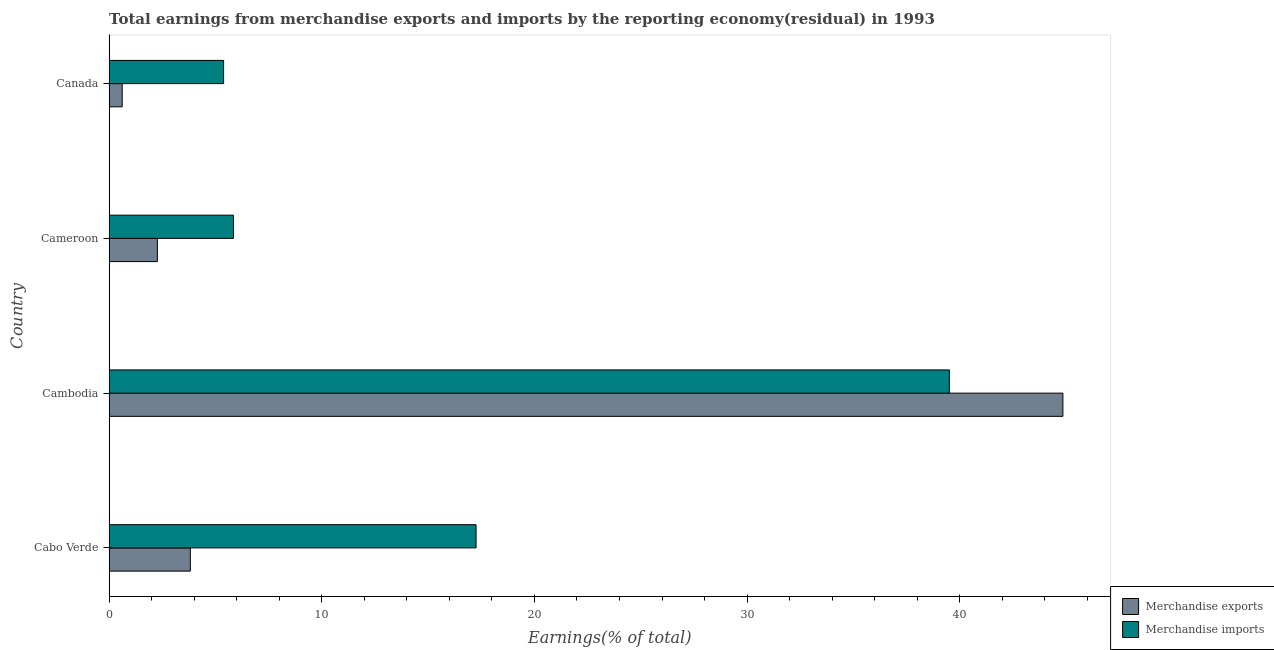How many groups of bars are there?
Offer a very short reply. 4. Are the number of bars per tick equal to the number of legend labels?
Offer a terse response. Yes. In how many cases, is the number of bars for a given country not equal to the number of legend labels?
Offer a terse response. 0. What is the earnings from merchandise exports in Cameroon?
Offer a very short reply. 2.27. Across all countries, what is the maximum earnings from merchandise imports?
Offer a very short reply. 39.51. Across all countries, what is the minimum earnings from merchandise imports?
Give a very brief answer. 5.39. In which country was the earnings from merchandise exports maximum?
Ensure brevity in your answer.  Cambodia. What is the total earnings from merchandise exports in the graph?
Ensure brevity in your answer.  51.56. What is the difference between the earnings from merchandise imports in Cabo Verde and that in Cambodia?
Make the answer very short. -22.26. What is the difference between the earnings from merchandise imports in Cameroon and the earnings from merchandise exports in Cabo Verde?
Keep it short and to the point. 2.03. What is the average earnings from merchandise exports per country?
Provide a short and direct response. 12.89. What is the difference between the earnings from merchandise exports and earnings from merchandise imports in Canada?
Offer a terse response. -4.77. In how many countries, is the earnings from merchandise exports greater than 14 %?
Ensure brevity in your answer.  1. What is the ratio of the earnings from merchandise imports in Cabo Verde to that in Canada?
Give a very brief answer. 3.2. What is the difference between the highest and the second highest earnings from merchandise imports?
Provide a short and direct response. 22.26. What is the difference between the highest and the lowest earnings from merchandise exports?
Offer a terse response. 44.23. In how many countries, is the earnings from merchandise imports greater than the average earnings from merchandise imports taken over all countries?
Keep it short and to the point. 2. Is the sum of the earnings from merchandise exports in Cameroon and Canada greater than the maximum earnings from merchandise imports across all countries?
Give a very brief answer. No. What does the 1st bar from the top in Canada represents?
Keep it short and to the point. Merchandise imports. What does the 2nd bar from the bottom in Canada represents?
Offer a terse response. Merchandise imports. How many bars are there?
Offer a terse response. 8. How many countries are there in the graph?
Your answer should be very brief. 4. What is the difference between two consecutive major ticks on the X-axis?
Offer a terse response. 10. Are the values on the major ticks of X-axis written in scientific E-notation?
Your response must be concise. No. Does the graph contain any zero values?
Your answer should be compact. No. How many legend labels are there?
Ensure brevity in your answer.  2. What is the title of the graph?
Give a very brief answer. Total earnings from merchandise exports and imports by the reporting economy(residual) in 1993. What is the label or title of the X-axis?
Your response must be concise. Earnings(% of total). What is the label or title of the Y-axis?
Ensure brevity in your answer.  Country. What is the Earnings(% of total) of Merchandise exports in Cabo Verde?
Provide a short and direct response. 3.82. What is the Earnings(% of total) in Merchandise imports in Cabo Verde?
Ensure brevity in your answer.  17.26. What is the Earnings(% of total) of Merchandise exports in Cambodia?
Make the answer very short. 44.85. What is the Earnings(% of total) of Merchandise imports in Cambodia?
Offer a very short reply. 39.51. What is the Earnings(% of total) of Merchandise exports in Cameroon?
Offer a very short reply. 2.27. What is the Earnings(% of total) in Merchandise imports in Cameroon?
Provide a short and direct response. 5.85. What is the Earnings(% of total) of Merchandise exports in Canada?
Ensure brevity in your answer.  0.62. What is the Earnings(% of total) of Merchandise imports in Canada?
Your response must be concise. 5.39. Across all countries, what is the maximum Earnings(% of total) of Merchandise exports?
Offer a terse response. 44.85. Across all countries, what is the maximum Earnings(% of total) of Merchandise imports?
Offer a very short reply. 39.51. Across all countries, what is the minimum Earnings(% of total) in Merchandise exports?
Keep it short and to the point. 0.62. Across all countries, what is the minimum Earnings(% of total) in Merchandise imports?
Provide a succinct answer. 5.39. What is the total Earnings(% of total) of Merchandise exports in the graph?
Give a very brief answer. 51.56. What is the total Earnings(% of total) of Merchandise imports in the graph?
Your response must be concise. 68. What is the difference between the Earnings(% of total) of Merchandise exports in Cabo Verde and that in Cambodia?
Offer a terse response. -41.03. What is the difference between the Earnings(% of total) of Merchandise imports in Cabo Verde and that in Cambodia?
Your answer should be compact. -22.26. What is the difference between the Earnings(% of total) in Merchandise exports in Cabo Verde and that in Cameroon?
Offer a very short reply. 1.55. What is the difference between the Earnings(% of total) of Merchandise imports in Cabo Verde and that in Cameroon?
Provide a short and direct response. 11.41. What is the difference between the Earnings(% of total) of Merchandise exports in Cabo Verde and that in Canada?
Ensure brevity in your answer.  3.2. What is the difference between the Earnings(% of total) of Merchandise imports in Cabo Verde and that in Canada?
Your response must be concise. 11.87. What is the difference between the Earnings(% of total) in Merchandise exports in Cambodia and that in Cameroon?
Keep it short and to the point. 42.58. What is the difference between the Earnings(% of total) of Merchandise imports in Cambodia and that in Cameroon?
Your response must be concise. 33.66. What is the difference between the Earnings(% of total) in Merchandise exports in Cambodia and that in Canada?
Ensure brevity in your answer.  44.23. What is the difference between the Earnings(% of total) in Merchandise imports in Cambodia and that in Canada?
Offer a very short reply. 34.13. What is the difference between the Earnings(% of total) in Merchandise exports in Cameroon and that in Canada?
Keep it short and to the point. 1.65. What is the difference between the Earnings(% of total) of Merchandise imports in Cameroon and that in Canada?
Offer a terse response. 0.46. What is the difference between the Earnings(% of total) in Merchandise exports in Cabo Verde and the Earnings(% of total) in Merchandise imports in Cambodia?
Your response must be concise. -35.69. What is the difference between the Earnings(% of total) in Merchandise exports in Cabo Verde and the Earnings(% of total) in Merchandise imports in Cameroon?
Provide a succinct answer. -2.03. What is the difference between the Earnings(% of total) in Merchandise exports in Cabo Verde and the Earnings(% of total) in Merchandise imports in Canada?
Provide a short and direct response. -1.56. What is the difference between the Earnings(% of total) of Merchandise exports in Cambodia and the Earnings(% of total) of Merchandise imports in Cameroon?
Make the answer very short. 39. What is the difference between the Earnings(% of total) in Merchandise exports in Cambodia and the Earnings(% of total) in Merchandise imports in Canada?
Make the answer very short. 39.47. What is the difference between the Earnings(% of total) of Merchandise exports in Cameroon and the Earnings(% of total) of Merchandise imports in Canada?
Ensure brevity in your answer.  -3.12. What is the average Earnings(% of total) in Merchandise exports per country?
Give a very brief answer. 12.89. What is the average Earnings(% of total) in Merchandise imports per country?
Offer a terse response. 17. What is the difference between the Earnings(% of total) in Merchandise exports and Earnings(% of total) in Merchandise imports in Cabo Verde?
Provide a succinct answer. -13.44. What is the difference between the Earnings(% of total) in Merchandise exports and Earnings(% of total) in Merchandise imports in Cambodia?
Make the answer very short. 5.34. What is the difference between the Earnings(% of total) in Merchandise exports and Earnings(% of total) in Merchandise imports in Cameroon?
Keep it short and to the point. -3.58. What is the difference between the Earnings(% of total) of Merchandise exports and Earnings(% of total) of Merchandise imports in Canada?
Your answer should be compact. -4.77. What is the ratio of the Earnings(% of total) of Merchandise exports in Cabo Verde to that in Cambodia?
Offer a very short reply. 0.09. What is the ratio of the Earnings(% of total) of Merchandise imports in Cabo Verde to that in Cambodia?
Make the answer very short. 0.44. What is the ratio of the Earnings(% of total) of Merchandise exports in Cabo Verde to that in Cameroon?
Your response must be concise. 1.68. What is the ratio of the Earnings(% of total) in Merchandise imports in Cabo Verde to that in Cameroon?
Keep it short and to the point. 2.95. What is the ratio of the Earnings(% of total) of Merchandise exports in Cabo Verde to that in Canada?
Provide a succinct answer. 6.19. What is the ratio of the Earnings(% of total) of Merchandise imports in Cabo Verde to that in Canada?
Make the answer very short. 3.2. What is the ratio of the Earnings(% of total) in Merchandise exports in Cambodia to that in Cameroon?
Keep it short and to the point. 19.76. What is the ratio of the Earnings(% of total) in Merchandise imports in Cambodia to that in Cameroon?
Your answer should be very brief. 6.76. What is the ratio of the Earnings(% of total) of Merchandise exports in Cambodia to that in Canada?
Your response must be concise. 72.66. What is the ratio of the Earnings(% of total) of Merchandise imports in Cambodia to that in Canada?
Offer a terse response. 7.34. What is the ratio of the Earnings(% of total) in Merchandise exports in Cameroon to that in Canada?
Ensure brevity in your answer.  3.68. What is the ratio of the Earnings(% of total) in Merchandise imports in Cameroon to that in Canada?
Ensure brevity in your answer.  1.09. What is the difference between the highest and the second highest Earnings(% of total) of Merchandise exports?
Offer a terse response. 41.03. What is the difference between the highest and the second highest Earnings(% of total) in Merchandise imports?
Your answer should be very brief. 22.26. What is the difference between the highest and the lowest Earnings(% of total) in Merchandise exports?
Keep it short and to the point. 44.23. What is the difference between the highest and the lowest Earnings(% of total) in Merchandise imports?
Keep it short and to the point. 34.13. 